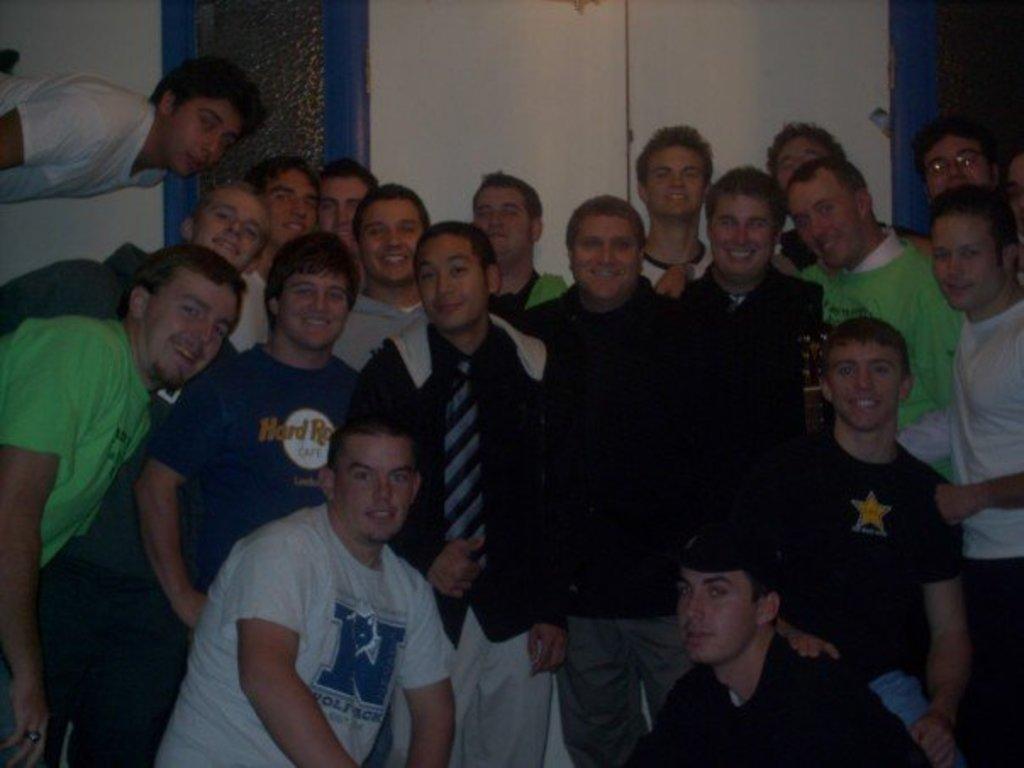Could you give a brief overview of what you see in this image? There is a group of persons standing as we can see in the middle of this image. There is a wall in the background. 